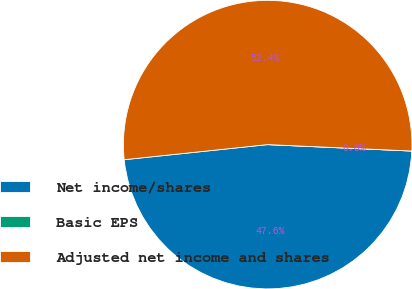Convert chart to OTSL. <chart><loc_0><loc_0><loc_500><loc_500><pie_chart><fcel>Net income/shares<fcel>Basic EPS<fcel>Adjusted net income and shares<nl><fcel>47.62%<fcel>0.0%<fcel>52.38%<nl></chart> 